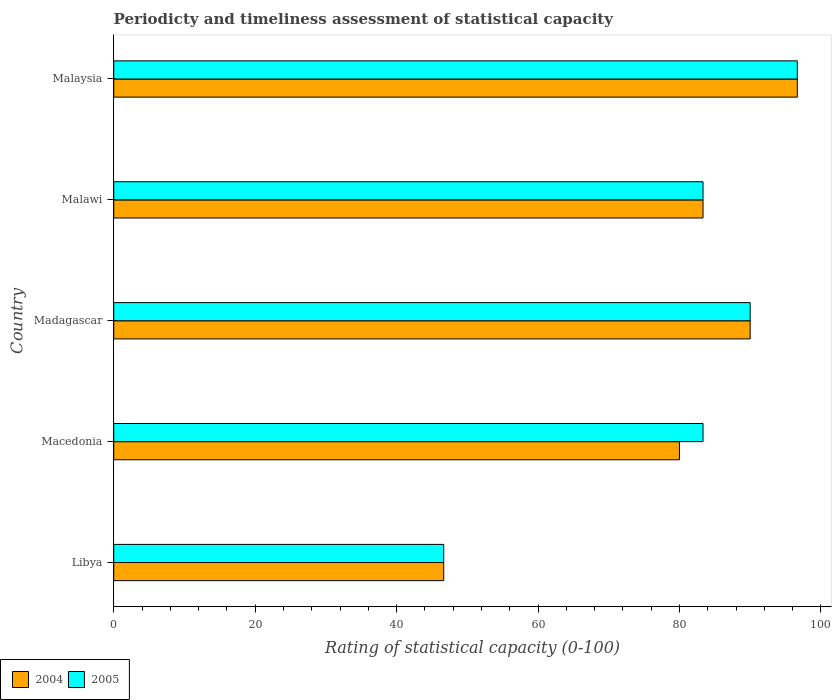How many bars are there on the 4th tick from the bottom?
Give a very brief answer. 2. What is the label of the 5th group of bars from the top?
Provide a succinct answer. Libya. What is the rating of statistical capacity in 2005 in Libya?
Make the answer very short. 46.67. Across all countries, what is the maximum rating of statistical capacity in 2004?
Give a very brief answer. 96.67. Across all countries, what is the minimum rating of statistical capacity in 2005?
Make the answer very short. 46.67. In which country was the rating of statistical capacity in 2005 maximum?
Give a very brief answer. Malaysia. In which country was the rating of statistical capacity in 2005 minimum?
Keep it short and to the point. Libya. What is the total rating of statistical capacity in 2004 in the graph?
Provide a succinct answer. 396.67. What is the difference between the rating of statistical capacity in 2004 in Libya and that in Malawi?
Provide a short and direct response. -36.67. What is the difference between the rating of statistical capacity in 2005 in Malawi and the rating of statistical capacity in 2004 in Malaysia?
Make the answer very short. -13.33. In how many countries, is the rating of statistical capacity in 2005 greater than 88 ?
Your answer should be compact. 2. What is the ratio of the rating of statistical capacity in 2005 in Malawi to that in Malaysia?
Offer a very short reply. 0.86. Is the rating of statistical capacity in 2004 in Macedonia less than that in Malaysia?
Keep it short and to the point. Yes. What is the difference between the highest and the second highest rating of statistical capacity in 2005?
Provide a short and direct response. 6.67. What is the difference between the highest and the lowest rating of statistical capacity in 2004?
Provide a succinct answer. 50. In how many countries, is the rating of statistical capacity in 2004 greater than the average rating of statistical capacity in 2004 taken over all countries?
Offer a very short reply. 4. What does the 2nd bar from the top in Malawi represents?
Ensure brevity in your answer.  2004. How many bars are there?
Give a very brief answer. 10. How many countries are there in the graph?
Offer a terse response. 5. Are the values on the major ticks of X-axis written in scientific E-notation?
Make the answer very short. No. Does the graph contain grids?
Ensure brevity in your answer.  No. Where does the legend appear in the graph?
Make the answer very short. Bottom left. How are the legend labels stacked?
Your answer should be very brief. Horizontal. What is the title of the graph?
Give a very brief answer. Periodicty and timeliness assessment of statistical capacity. Does "2010" appear as one of the legend labels in the graph?
Ensure brevity in your answer.  No. What is the label or title of the X-axis?
Your answer should be compact. Rating of statistical capacity (0-100). What is the Rating of statistical capacity (0-100) of 2004 in Libya?
Ensure brevity in your answer.  46.67. What is the Rating of statistical capacity (0-100) in 2005 in Libya?
Your response must be concise. 46.67. What is the Rating of statistical capacity (0-100) in 2005 in Macedonia?
Offer a very short reply. 83.33. What is the Rating of statistical capacity (0-100) in 2004 in Madagascar?
Keep it short and to the point. 90. What is the Rating of statistical capacity (0-100) in 2004 in Malawi?
Ensure brevity in your answer.  83.33. What is the Rating of statistical capacity (0-100) of 2005 in Malawi?
Your answer should be compact. 83.33. What is the Rating of statistical capacity (0-100) of 2004 in Malaysia?
Provide a short and direct response. 96.67. What is the Rating of statistical capacity (0-100) of 2005 in Malaysia?
Provide a succinct answer. 96.67. Across all countries, what is the maximum Rating of statistical capacity (0-100) of 2004?
Offer a very short reply. 96.67. Across all countries, what is the maximum Rating of statistical capacity (0-100) in 2005?
Your answer should be compact. 96.67. Across all countries, what is the minimum Rating of statistical capacity (0-100) in 2004?
Your answer should be compact. 46.67. Across all countries, what is the minimum Rating of statistical capacity (0-100) in 2005?
Offer a terse response. 46.67. What is the total Rating of statistical capacity (0-100) in 2004 in the graph?
Keep it short and to the point. 396.67. What is the total Rating of statistical capacity (0-100) of 2005 in the graph?
Ensure brevity in your answer.  400. What is the difference between the Rating of statistical capacity (0-100) of 2004 in Libya and that in Macedonia?
Ensure brevity in your answer.  -33.33. What is the difference between the Rating of statistical capacity (0-100) of 2005 in Libya and that in Macedonia?
Your answer should be compact. -36.67. What is the difference between the Rating of statistical capacity (0-100) in 2004 in Libya and that in Madagascar?
Provide a succinct answer. -43.33. What is the difference between the Rating of statistical capacity (0-100) in 2005 in Libya and that in Madagascar?
Ensure brevity in your answer.  -43.33. What is the difference between the Rating of statistical capacity (0-100) in 2004 in Libya and that in Malawi?
Your answer should be very brief. -36.67. What is the difference between the Rating of statistical capacity (0-100) in 2005 in Libya and that in Malawi?
Provide a succinct answer. -36.67. What is the difference between the Rating of statistical capacity (0-100) in 2005 in Macedonia and that in Madagascar?
Make the answer very short. -6.67. What is the difference between the Rating of statistical capacity (0-100) of 2004 in Macedonia and that in Malaysia?
Ensure brevity in your answer.  -16.67. What is the difference between the Rating of statistical capacity (0-100) of 2005 in Macedonia and that in Malaysia?
Offer a very short reply. -13.33. What is the difference between the Rating of statistical capacity (0-100) in 2004 in Madagascar and that in Malawi?
Provide a succinct answer. 6.67. What is the difference between the Rating of statistical capacity (0-100) of 2004 in Madagascar and that in Malaysia?
Ensure brevity in your answer.  -6.67. What is the difference between the Rating of statistical capacity (0-100) of 2005 in Madagascar and that in Malaysia?
Your answer should be compact. -6.67. What is the difference between the Rating of statistical capacity (0-100) of 2004 in Malawi and that in Malaysia?
Provide a short and direct response. -13.33. What is the difference between the Rating of statistical capacity (0-100) of 2005 in Malawi and that in Malaysia?
Ensure brevity in your answer.  -13.33. What is the difference between the Rating of statistical capacity (0-100) in 2004 in Libya and the Rating of statistical capacity (0-100) in 2005 in Macedonia?
Make the answer very short. -36.67. What is the difference between the Rating of statistical capacity (0-100) in 2004 in Libya and the Rating of statistical capacity (0-100) in 2005 in Madagascar?
Ensure brevity in your answer.  -43.33. What is the difference between the Rating of statistical capacity (0-100) of 2004 in Libya and the Rating of statistical capacity (0-100) of 2005 in Malawi?
Give a very brief answer. -36.67. What is the difference between the Rating of statistical capacity (0-100) in 2004 in Macedonia and the Rating of statistical capacity (0-100) in 2005 in Malawi?
Your answer should be compact. -3.33. What is the difference between the Rating of statistical capacity (0-100) in 2004 in Macedonia and the Rating of statistical capacity (0-100) in 2005 in Malaysia?
Keep it short and to the point. -16.67. What is the difference between the Rating of statistical capacity (0-100) in 2004 in Madagascar and the Rating of statistical capacity (0-100) in 2005 in Malawi?
Your response must be concise. 6.67. What is the difference between the Rating of statistical capacity (0-100) in 2004 in Madagascar and the Rating of statistical capacity (0-100) in 2005 in Malaysia?
Your response must be concise. -6.67. What is the difference between the Rating of statistical capacity (0-100) in 2004 in Malawi and the Rating of statistical capacity (0-100) in 2005 in Malaysia?
Offer a very short reply. -13.33. What is the average Rating of statistical capacity (0-100) in 2004 per country?
Ensure brevity in your answer.  79.33. What is the difference between the Rating of statistical capacity (0-100) in 2004 and Rating of statistical capacity (0-100) in 2005 in Macedonia?
Offer a very short reply. -3.33. What is the difference between the Rating of statistical capacity (0-100) of 2004 and Rating of statistical capacity (0-100) of 2005 in Madagascar?
Provide a succinct answer. 0. What is the difference between the Rating of statistical capacity (0-100) in 2004 and Rating of statistical capacity (0-100) in 2005 in Malawi?
Offer a very short reply. 0. What is the ratio of the Rating of statistical capacity (0-100) of 2004 in Libya to that in Macedonia?
Your answer should be very brief. 0.58. What is the ratio of the Rating of statistical capacity (0-100) of 2005 in Libya to that in Macedonia?
Provide a succinct answer. 0.56. What is the ratio of the Rating of statistical capacity (0-100) of 2004 in Libya to that in Madagascar?
Give a very brief answer. 0.52. What is the ratio of the Rating of statistical capacity (0-100) of 2005 in Libya to that in Madagascar?
Provide a succinct answer. 0.52. What is the ratio of the Rating of statistical capacity (0-100) of 2004 in Libya to that in Malawi?
Offer a terse response. 0.56. What is the ratio of the Rating of statistical capacity (0-100) in 2005 in Libya to that in Malawi?
Make the answer very short. 0.56. What is the ratio of the Rating of statistical capacity (0-100) in 2004 in Libya to that in Malaysia?
Ensure brevity in your answer.  0.48. What is the ratio of the Rating of statistical capacity (0-100) of 2005 in Libya to that in Malaysia?
Provide a succinct answer. 0.48. What is the ratio of the Rating of statistical capacity (0-100) of 2004 in Macedonia to that in Madagascar?
Provide a short and direct response. 0.89. What is the ratio of the Rating of statistical capacity (0-100) in 2005 in Macedonia to that in Madagascar?
Make the answer very short. 0.93. What is the ratio of the Rating of statistical capacity (0-100) of 2004 in Macedonia to that in Malawi?
Make the answer very short. 0.96. What is the ratio of the Rating of statistical capacity (0-100) in 2004 in Macedonia to that in Malaysia?
Give a very brief answer. 0.83. What is the ratio of the Rating of statistical capacity (0-100) in 2005 in Macedonia to that in Malaysia?
Provide a short and direct response. 0.86. What is the ratio of the Rating of statistical capacity (0-100) of 2004 in Madagascar to that in Malaysia?
Make the answer very short. 0.93. What is the ratio of the Rating of statistical capacity (0-100) of 2005 in Madagascar to that in Malaysia?
Your answer should be compact. 0.93. What is the ratio of the Rating of statistical capacity (0-100) of 2004 in Malawi to that in Malaysia?
Ensure brevity in your answer.  0.86. What is the ratio of the Rating of statistical capacity (0-100) in 2005 in Malawi to that in Malaysia?
Keep it short and to the point. 0.86. What is the difference between the highest and the second highest Rating of statistical capacity (0-100) of 2004?
Give a very brief answer. 6.67. What is the difference between the highest and the lowest Rating of statistical capacity (0-100) of 2004?
Your answer should be compact. 50. What is the difference between the highest and the lowest Rating of statistical capacity (0-100) in 2005?
Provide a succinct answer. 50. 